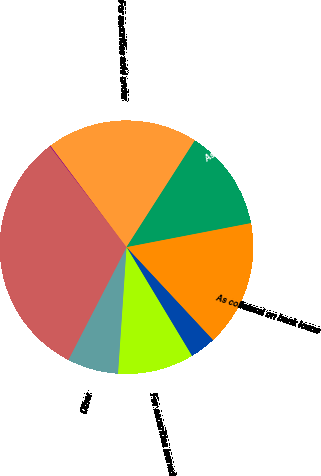Convert chart. <chart><loc_0><loc_0><loc_500><loc_500><pie_chart><fcel>In millions of dollars<fcel>For securities sold under<fcel>As collateral for securities<fcel>As collateral on bank loans<fcel>To clearing organizations or<fcel>For securities loaned<fcel>Other<fcel>Total<nl><fcel>0.12%<fcel>19.29%<fcel>12.9%<fcel>16.1%<fcel>3.31%<fcel>9.7%<fcel>6.51%<fcel>32.08%<nl></chart> 